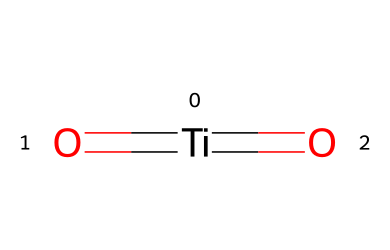How many titanium atoms are present in the chemical structure? The SMILES representation shows a single `[Ti]`, indicating there is one titanium atom in this molecule.
Answer: one What is the oxidation state of titanium in this structure? The presence of two oxygen double bonds (`=O`) suggests that titanium is in the +4 oxidation state, which is typical for titanium dioxide.
Answer: +4 How many oxygen atoms are bonded to titanium in this chemical? The chemical structure includes two `=O` indicators, meaning there are two oxygen atoms present, both double-bonded to the titanium atom.
Answer: two What is the general name of this chemical used in sunscreens? This chemical with the formula TiO2 is commonly known as titanium dioxide, which is widely used in sunscreens for its UV-filtering properties.
Answer: titanium dioxide Is this chemical considered an organometallic compound? Since titanium is a metal and there are carbon-containing compounds known as organometallics, but titanium dioxide does not contain carbon, this compound is not classified under organometallics.
Answer: no Which functional groups are present in this chemical structure? The chemical features titanium as a central atom bonded to oxygen in the form of double bonds, which can be categorized into oxo or carbonyl functional groups; however, the structure lacks typical organic functional groups due to the absence of carbon.
Answer: oxo groups 